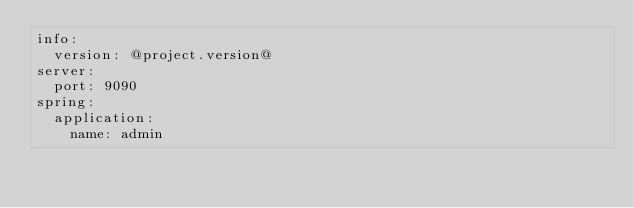Convert code to text. <code><loc_0><loc_0><loc_500><loc_500><_YAML_>info:
  version: @project.version@
server:
  port: 9090
spring:
  application:
    name: admin</code> 